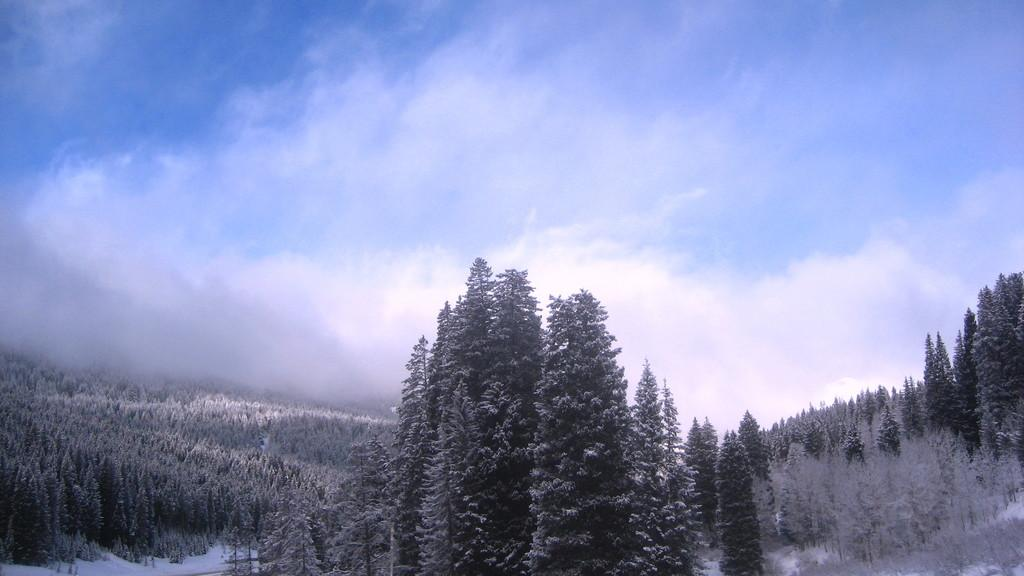What type of vegetation is present at the bottom of the image? There are trees at the bottom of the image. What is covering the ground at the bottom of the image? There is snow at the bottom of the image. What can be seen in the sky at the top of the image? There are clouds in the sky at the top of the image. What type of rhythm is being played by the trees in the image? There is no rhythm being played by the trees in the image, as trees are not capable of producing music or rhythm. 